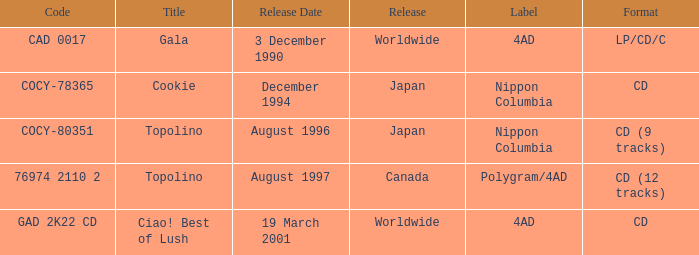What format was released in August 1996? CD (9 tracks). 